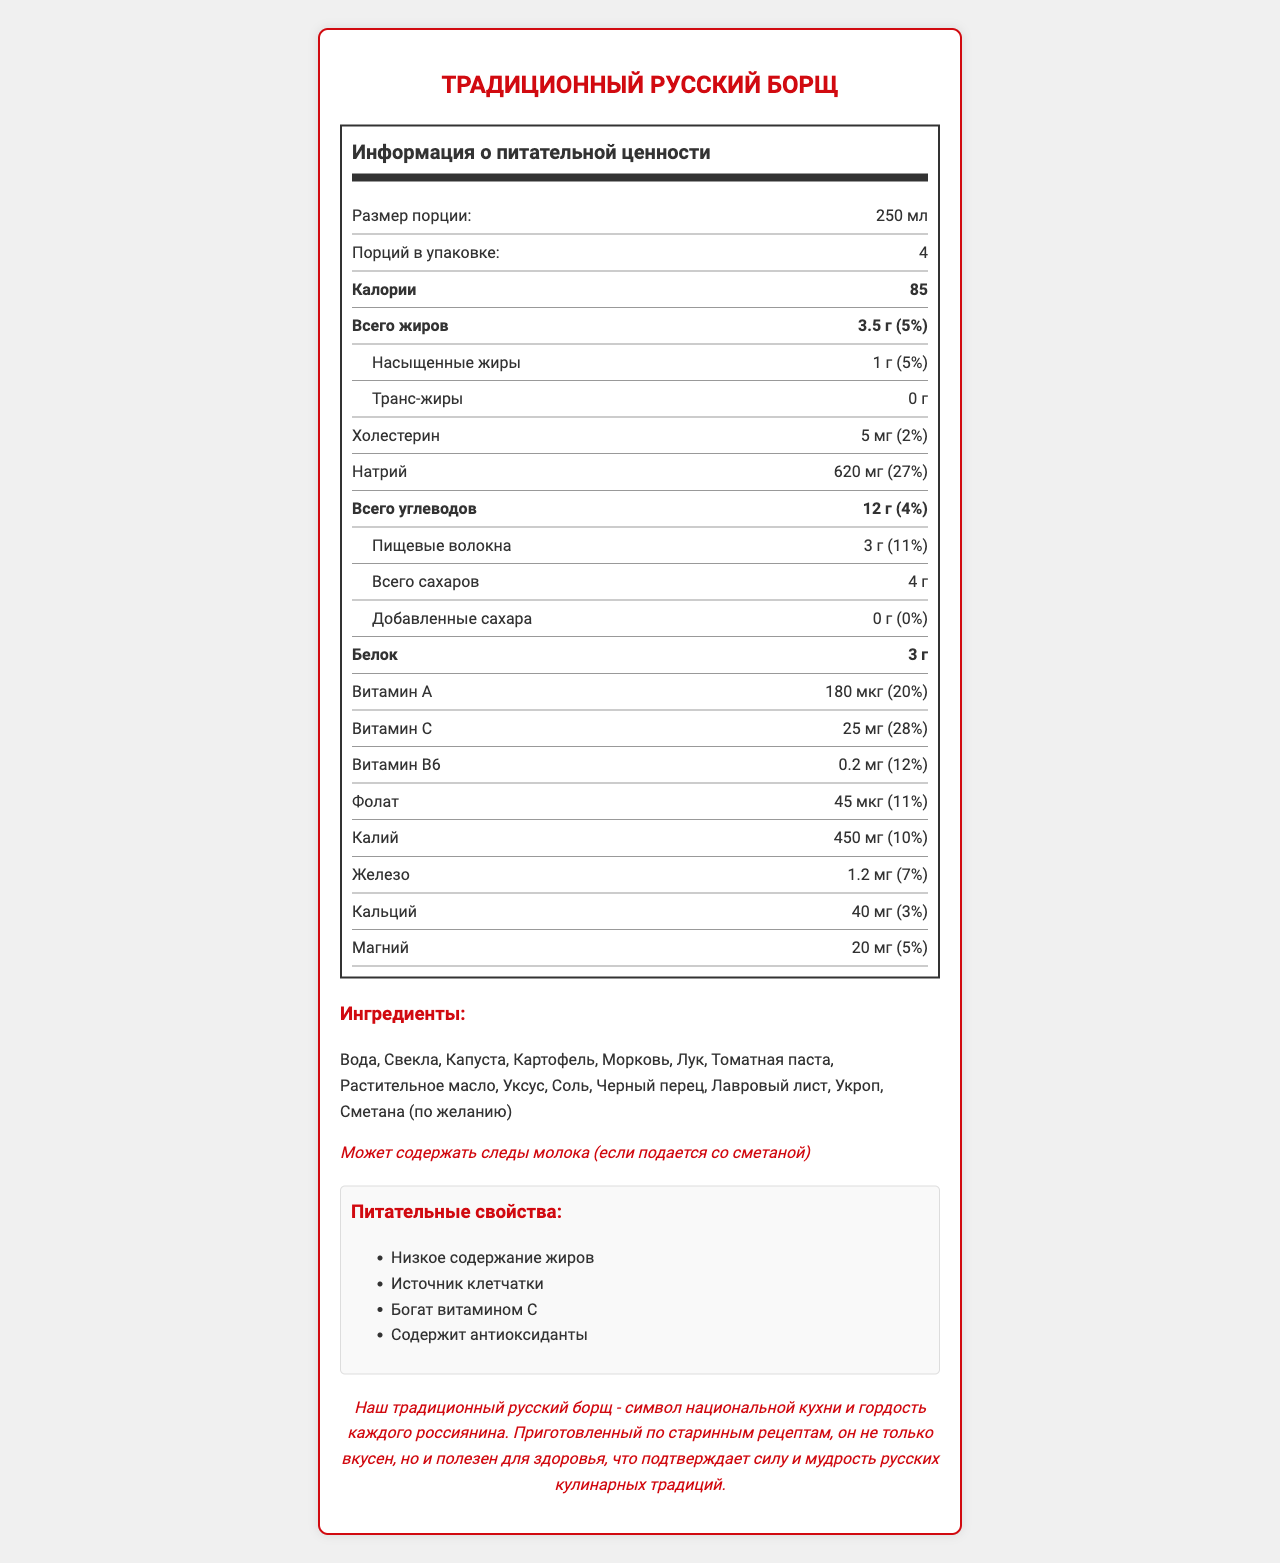what is the size of one serving? The document states that the serving size is 250 мл.
Answer: 250 мл how many servings are there per container? The document indicates that there are 4 servings per container.
Answer: 4 how many calories are there per serving? The document shows that each serving contains 85 calories.
Answer: 85 what is the total amount of fat per serving? According to the document, the total amount of fat per serving is 3.5 г.
Answer: 3.5 г how much protein is in one serving? The document states that one serving contains 3 г of protein.
Answer: 3 г how much saturated fat is there per serving? The document indicates that there is 1 г of saturated fat per serving.
Answer: 1 г how much sodium does one serving contain? The document shows that each serving contains 620 мг of sodium.
Answer: 620 мг how much dietary fiber is in one serving? The document states that there are 3 г of dietary fiber per serving.
Answer: 3 г how much sugar is there in one serving? A. 4 г B. 5 г C. 3 г D. 0 г The document indicates that the total sugar content per serving is 4 г.
Answer: A what percentage of the daily value of vitamin A does one serving provide? A. 10% B. 20% C. 30% D. 40% The document shows that one serving provides 20% of the daily value of vitamin A.
Answer: B does the product contain any added sugars? The document states that added sugars are 0 г, which means there are no added sugars.
Answer: No does the product contain any allergens? The product may contain traces of milk if served with sour cream (сметана).
Answer: Yes summarize the entire document The document offers comprehensive nutritional information, ingredient details, possible allergens, and some cultural context for traditional Russian borscht. It emphasizes the health benefits and cultural pride associated with the dish.
Answer: This document provides nutrition information for traditional Russian borscht, including serving size, number of servings, calories, macronutrients, and detailed vitamin and mineral content. It lists ingredients and mentions potential allergens. Additionally, it highlights the nutritional benefits and includes a patriotic statement about the cultural significance of the dish. how much magnesium is in one serving? The document specifies that one serving contains 20 мг of magnesium.
Answer: 20 мг what is the main protein content source listed among the ingredients? The document does not specify the sources of protein among the listed ingredients.
Answer: Cannot be determined how much cholesterol does one serving contain? The document indicates that each serving contains 5 мг of cholesterol.
Answer: 5 мг what is the daily value percentage of potassium provided by one serving? The document states that one serving provides 10% of the daily value of potassium.
Answer: 10% what are the nutritional claims listed for this product? The document lists the following nutritional claims: Низкое содержание жиров, Источник клетчатки, Богат витамином C, Содержит антиоксиданты.
Answer: Низкое содержание жиров, Источник клетчатки, Богат витамином C, Содержит антиоксиданты what is the patriotic statement in the document? The document includes the patriotic statement: Наш традиционный русский борщ - символ национальной кухни и гордость каждого россиянина. Приготовленный по старинным рецептам, он не только вкусен, но и полезен для здоровья, что подтверждает силу и мудрость русских кулинарных традиций.
Answer: Наш традиционный русский борщ - символ национальной кухни и гордость каждого россиянина. Приготовленный по старинным рецептам, он не только вкусен, но и полезен для здоровья, что подтверждает силу и мудрость русских кулинарных традиций. 